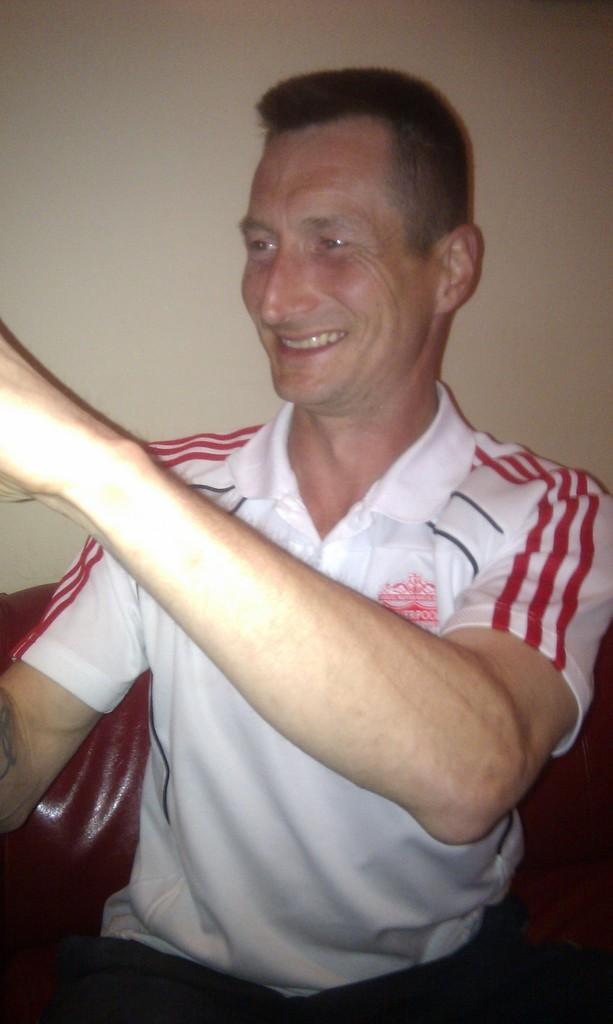What is the person in the image doing? The person is sitting on a chair in the image. What is the person's facial expression? The person is smiling. What is the person wearing? The person is wearing a white t-shirt. What can be seen in the background of the image? There is a wall in the background of the image. What type of lumber is being used to construct the chair in the image? There is no mention of lumber or the construction of the chair in the image. The chair's material is not specified. 